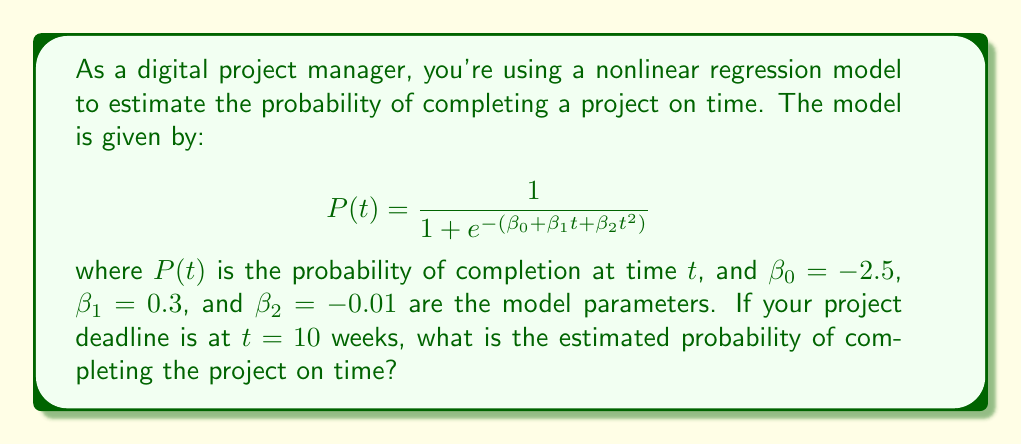Could you help me with this problem? To solve this problem, we'll follow these steps:

1) We have the logistic regression model:
   $$P(t) = \frac{1}{1 + e^{-(\beta_0 + \beta_1t + \beta_2t^2)}}$$

2) We're given the parameter values:
   $\beta_0 = -2.5$
   $\beta_1 = 0.3$
   $\beta_2 = -0.01$

3) We need to calculate $P(t)$ at $t = 10$ weeks.

4) Let's first calculate the exponent:
   $$\beta_0 + \beta_1t + \beta_2t^2 = -2.5 + 0.3(10) + (-0.01)(10^2)$$
   $$= -2.5 + 3 - 1 = -0.5$$

5) Now, we can plug this into our equation:
   $$P(10) = \frac{1}{1 + e^{-(-0.5)}} = \frac{1}{1 + e^{0.5}}$$

6) Calculate $e^{0.5} \approx 1.6487$

7) Finally, calculate the probability:
   $$P(10) = \frac{1}{1 + 1.6487} \approx 0.3775$$

8) Convert to a percentage: 0.3775 * 100% = 37.75%
Answer: 37.75% 